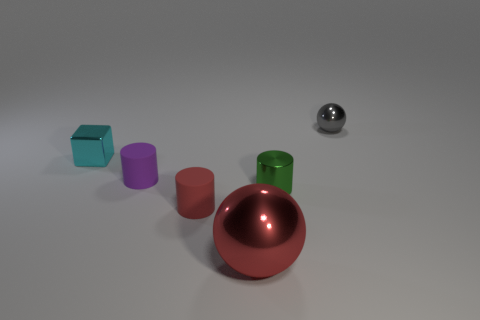Are there any patterns or textures on the objects that can give us more details about them? The objects don't have visible patterns, but textures are distinguishable. The metallic objects have a smooth, reflective surface indicating a polished finish, while the matte objects possess a slightly textured surface, akin to painted or coated plastic. 